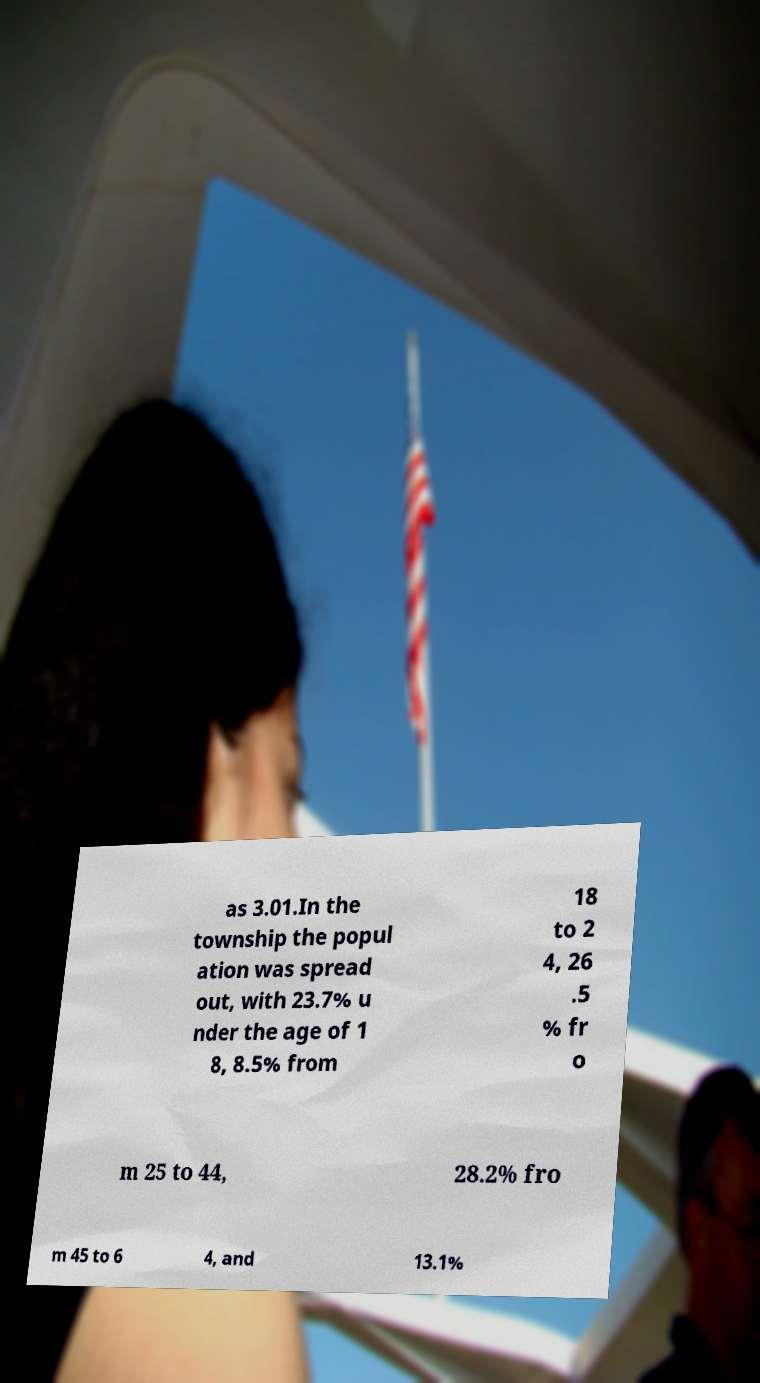For documentation purposes, I need the text within this image transcribed. Could you provide that? as 3.01.In the township the popul ation was spread out, with 23.7% u nder the age of 1 8, 8.5% from 18 to 2 4, 26 .5 % fr o m 25 to 44, 28.2% fro m 45 to 6 4, and 13.1% 